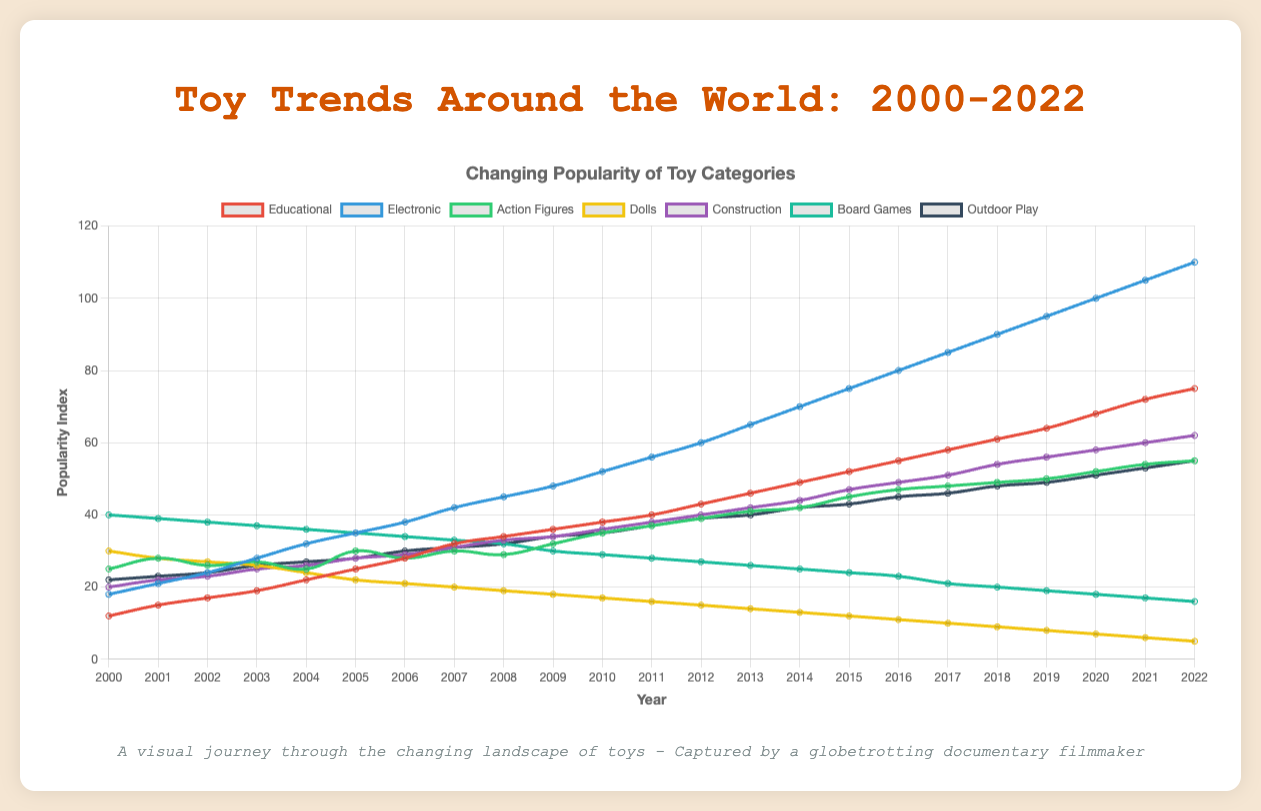Which toy category has the highest popularity in 2022? By observing the figure, we can see that the 'Electronic' category has the line that reaches the highest value, which is 110 in 2022.
Answer: Electronic Which category experienced the largest decrease in popularity from 2000 to 2022? By examining the lines and their trends, we can see that 'Dolls' had the most significant decline, dropping from 30 in 2000 to 5 in 2022.
Answer: Dolls How much did the popularity of Educational toys increase from 2010 to 2022? The Educational category's popularity increased from 38 in 2010 to 75 in 2022. The difference is 75 - 38.
Answer: 37 Among the categories, which one remained relatively stable between 2000 and 2022? By looking at the trends, 'Action Figures' maintained a relatively stable popularity with slight fluctuations compared to other categories.
Answer: Action Figures What is the average popularity of the Construction toys between 2008 and 2016? The values for Construction toys between 2008 and 2016 are 33, 34, 36, 38, 40, 42, 44, and 47. The average is (33 + 34 + 36 + 38 + 40 + 42 + 44 + 47) / 8.
Answer: 39.25 By what percentage did Board Games' popularity change from 2010 to 2022? The popularity of Board Games decreased from 29 in 2010 to 16 in 2022. The percentage change is ((16 - 29) / 29) * 100.
Answer: -44.83% Which toy category had the highest growth rate from 2000 to 2022? Observing the overall trends and endpoints, we see that 'Electronic' toys grew from 18 to 110. The growth rate is ((110-18)/18) * 100.
Answer: 511.11% In which period did the popularity of Outdoor Play toys see the most significant growth, and by how much? The most significant growth for Outdoor Play toys occurred between 2016 (45) and 2018 (48), with an increase of 48 - 45.
Answer: 3 Which category had a higher popularity in 2011, Electronic or Construction toys? Referring to the figure, in 2011, Electronic toys had a popularity of 56, while Construction toys had a popularity of 38.
Answer: Electronic What is the difference in popularity between Board Games and Dolls in 2005? In 2005, the popularity values were 35 for Board Games and 22 for Dolls. The difference is 35 - 22.
Answer: 13 